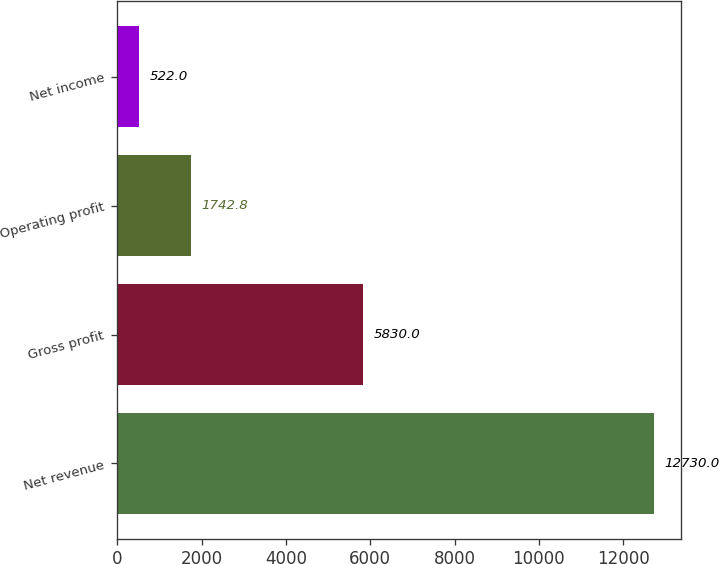Convert chart. <chart><loc_0><loc_0><loc_500><loc_500><bar_chart><fcel>Net revenue<fcel>Gross profit<fcel>Operating profit<fcel>Net income<nl><fcel>12730<fcel>5830<fcel>1742.8<fcel>522<nl></chart> 